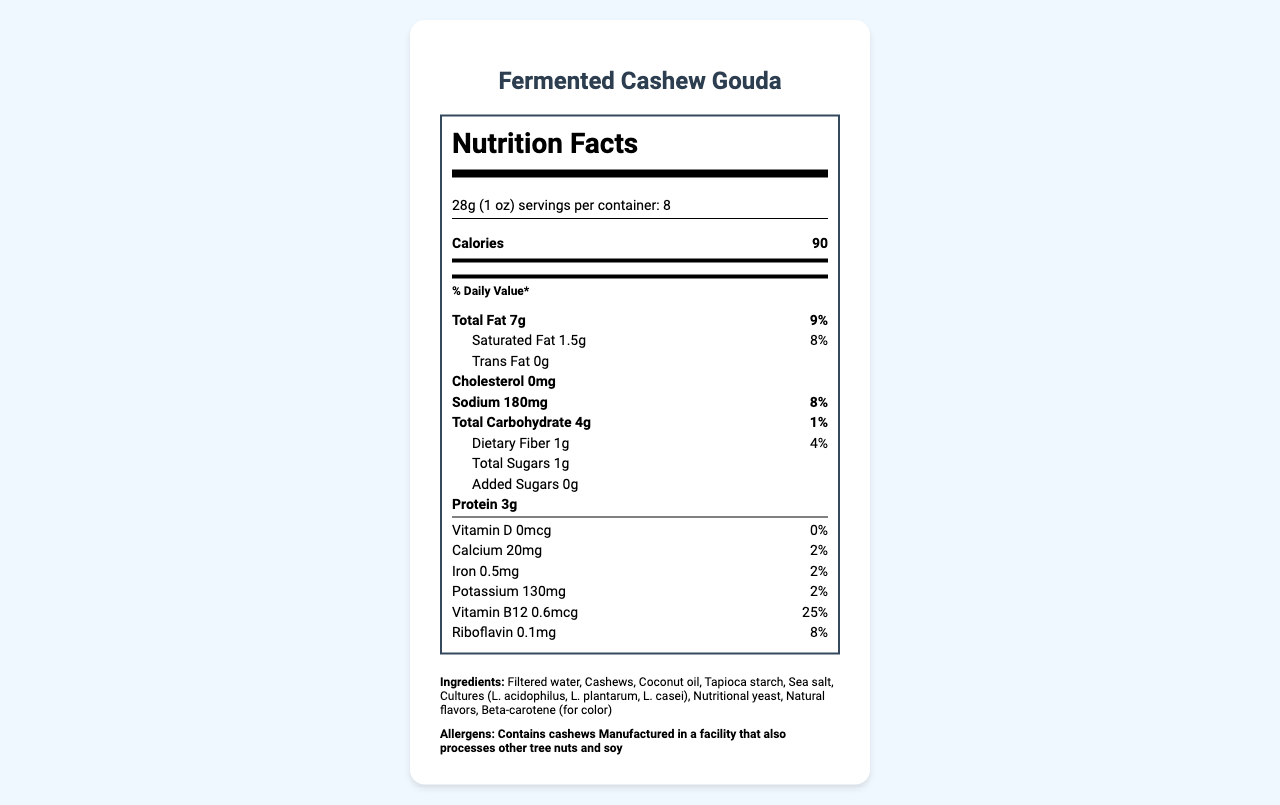what is the product name? The product name is listed at the top of the document and in the header section.
Answer: Fermented Cashew Gouda what is the serving size? The serving size is mentioned under the Nutrition Facts section in the document.
Answer: 28g (1 oz) how many servings per container? This information is located under the serving size in the Nutrition Facts section.
Answer: 8 how many calories per serving? The number of calories per serving is directly stated in the Nutrition Facts section next to Calories.
Answer: 90 what is the total fat content per serving? This information is listed under the Total Fat label in the Nutrition Facts section.
Answer: 7g how much sodium does one serving contain? The sodium content per serving is provided under the Sodium label in the Nutrition Facts section.
Answer: 180mg what percentage of the daily value does the saturated fat amount to? The daily value percentage for saturated fat is mentioned next to its amount in the Nutrition Facts section.
Answer: 8% does the product contain trans fat? The document states that the Trans Fat content is 0g, indicating there are no trans fats in the product.
Answer: No is cholesterol present in the product? The document states that the Cholesterol content is 0mg, indicating no cholesterol is present.
Answer: No what are the allergens listed? The allergens are mentioned in a separate section labeled Allergens.
Answer: Contains cashews, Manufactured in a facility that also processes other tree nuts and soy what is the main ingredient in the product? A. Cashews B. Filtered water C. Coconut oil D. Sea salt The first ingredient listed is Filtered water, which usually indicates it is the main ingredient.
Answer: B. Filtered water how much protein does one serving provide? A. 2g B. 3g C. 4g D. 5g The amount of protein per serving is listed as 3g in the Nutrition Facts section.
Answer: B. 3g is this product suitable for someone avoiding soy? Although the product itself does not list soy in its ingredients, it is manufactured in a facility that also processes soy, which could pose a risk.
Answer: Cannot be determined which vitamins and minerals are present in this product? The Nutrition Facts section lists these vitamins and minerals with their amounts and daily values.
Answer: Vitamin D, Calcium, Iron, Potassium, Vitamin B12, Riboflavin describe the nutrition information available in the document. This summary captures the entirety of the Nutrition Facts as well as all additional product information provided in the document.
Answer: The document provides a comprehensive breakdown of the nutritional content of Fermented Cashew Gouda. It includes serving size, servings per container, calories, total fat, saturated fat, trans fat, cholesterol, sodium, carbohydrates, dietary fiber, total sugars, added sugars, protein, vitamins, and minerals. The ingredients, allergen information, and additional product details such as the fermentation process, texture enhancers, flavor compounds, shelf life, pH, moisture content, meltability score, and stretchability score are also listed. what are the texture enhancers used in this product? The texture enhancers are specifically listed in the document under the Texture Enhancers section.
Answer: Carrageenan, Locust bean gum what is the meltability score of the product? The meltability score is directly provided in the lower section of the document.
Answer: 7.5 how much calcium does this product provide per serving? The amount of calcium per serving is listed in the Nutrition Facts section.
Answer: 20mg what is the moisture content of the product? The moisture content is explicitly stated near the additional product information sections.
Answer: 55% what are the flavor compounds used in this product? The flavor compounds are listed under the Flavor Compounds section of the document.
Answer: 2-Methyl-1-butanol, 3-Methylbutanal, Ethyl butyrate, Diacetyl is this product vegan? The document does not explicitly state whether the product is vegan, so this information cannot be conclusively determined from the provided details.
Answer: Cannot be determined 